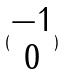Convert formula to latex. <formula><loc_0><loc_0><loc_500><loc_500>( \begin{matrix} - 1 \\ 0 \end{matrix} )</formula> 